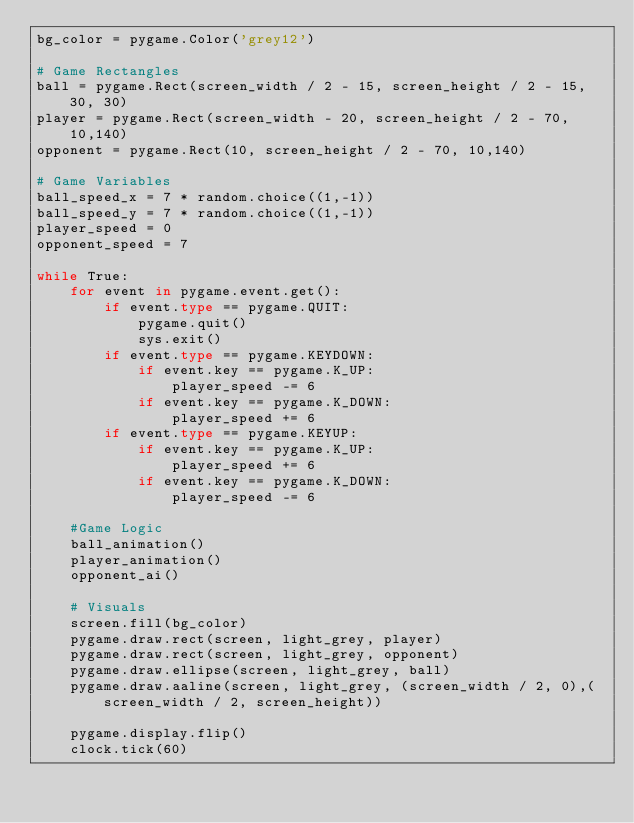Convert code to text. <code><loc_0><loc_0><loc_500><loc_500><_Python_>bg_color = pygame.Color('grey12')

# Game Rectangles
ball = pygame.Rect(screen_width / 2 - 15, screen_height / 2 - 15, 30, 30)
player = pygame.Rect(screen_width - 20, screen_height / 2 - 70, 10,140)
opponent = pygame.Rect(10, screen_height / 2 - 70, 10,140)

# Game Variables
ball_speed_x = 7 * random.choice((1,-1))
ball_speed_y = 7 * random.choice((1,-1))
player_speed = 0
opponent_speed = 7

while True:
	for event in pygame.event.get():
		if event.type == pygame.QUIT:
			pygame.quit()
			sys.exit()
		if event.type == pygame.KEYDOWN:
			if event.key == pygame.K_UP:
				player_speed -= 6
			if event.key == pygame.K_DOWN:
				player_speed += 6
		if event.type == pygame.KEYUP:
			if event.key == pygame.K_UP:
				player_speed += 6
			if event.key == pygame.K_DOWN:
				player_speed -= 6
	
	#Game Logic
	ball_animation()
	player_animation()
	opponent_ai()

	# Visuals 
	screen.fill(bg_color)
	pygame.draw.rect(screen, light_grey, player)
	pygame.draw.rect(screen, light_grey, opponent)
	pygame.draw.ellipse(screen, light_grey, ball)
	pygame.draw.aaline(screen, light_grey, (screen_width / 2, 0),(screen_width / 2, screen_height))

	pygame.display.flip()
	clock.tick(60)
</code> 